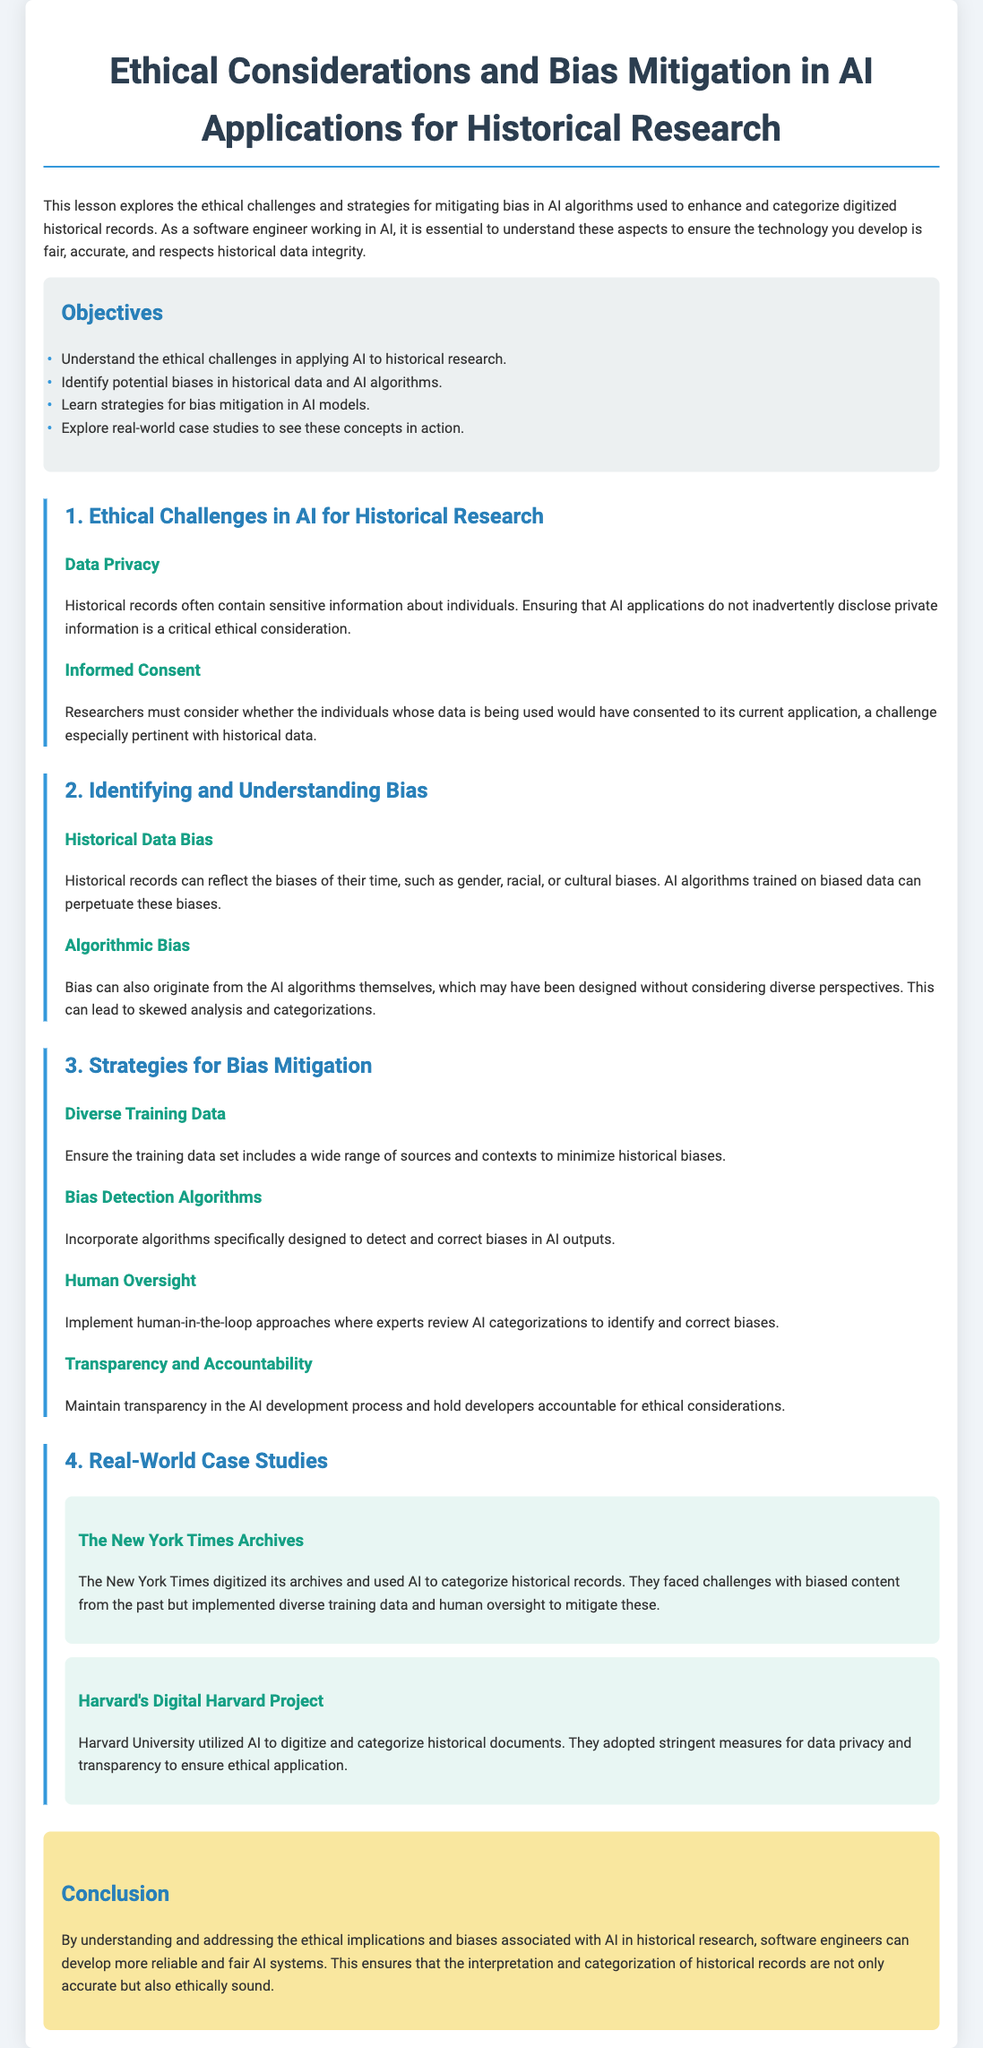What is the title of the lesson plan? The title can be found at the beginning of the document, which is "Ethical Considerations and Bias Mitigation in AI Applications for Historical Research."
Answer: Ethical Considerations and Bias Mitigation in AI Applications for Historical Research What is the first objective of the lesson? The first objective is listed under the objectives section, where it states "Understand the ethical challenges in applying AI to historical research."
Answer: Understand the ethical challenges in applying AI to historical research What are the two types of bias mentioned in the document? The document discusses "Historical Data Bias" and "Algorithmic Bias" as types of bias under the relevant section.
Answer: Historical Data Bias and Algorithmic Bias Name one strategy for bias mitigation. The document includes several strategies, one of which is "Diverse Training Data."
Answer: Diverse Training Data Which case study involves the New York Times? The New York Times is mentioned in the real-world case studies section, specifically titled "The New York Times Archives."
Answer: The New York Times Archives What is the color of the objectives section background? The objectives section background color is described in the style section of the document as "light grey."
Answer: Light grey How many real-world case studies are included in the lesson plan? The document lists two real-world case studies, which can be counted under the corresponding section.
Answer: Two What ethical consideration relates to individual data? The document highlights "Data Privacy" as an ethical consideration concerning sensitive information about individuals.
Answer: Data Privacy What is a key method emphasized for maintaining ethical AI development? The document discusses "Transparency and Accountability" as a significant focus for ethical considerations in AI development.
Answer: Transparency and Accountability 